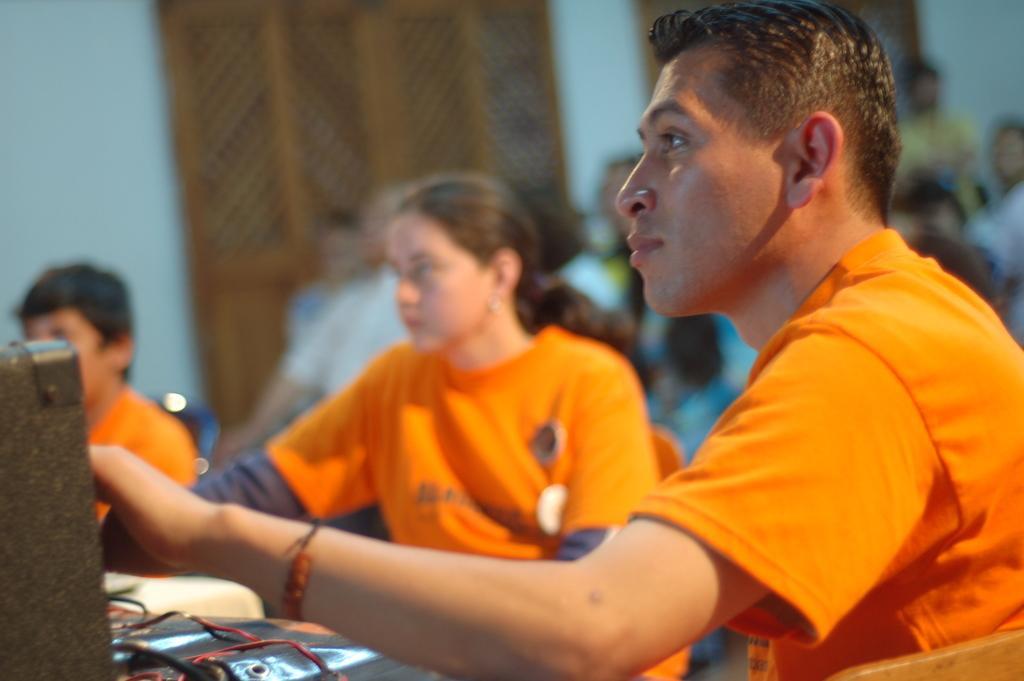In one or two sentences, can you explain what this image depicts? In the center of the image a group of people are sitting on the chairs. On the left side of the image there is a table. On the we can see some objects. In the background of the image we can see wall, boards. 